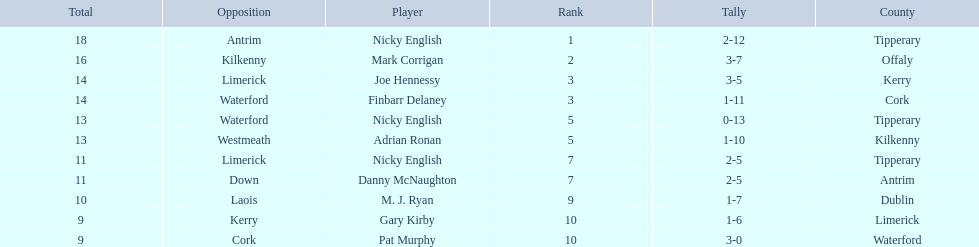Joe hennessy and finbarr delaney both scored how many points? 14. 